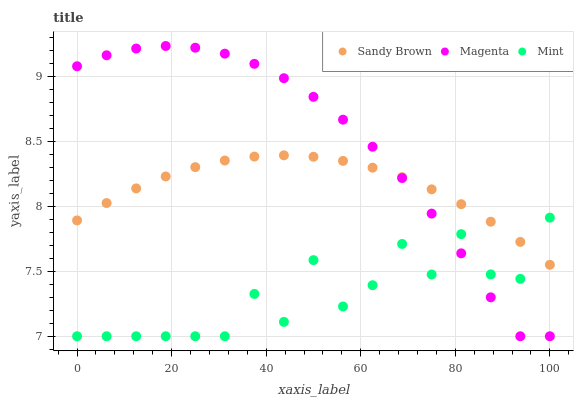Does Mint have the minimum area under the curve?
Answer yes or no. Yes. Does Magenta have the maximum area under the curve?
Answer yes or no. Yes. Does Sandy Brown have the minimum area under the curve?
Answer yes or no. No. Does Sandy Brown have the maximum area under the curve?
Answer yes or no. No. Is Sandy Brown the smoothest?
Answer yes or no. Yes. Is Mint the roughest?
Answer yes or no. Yes. Is Magenta the smoothest?
Answer yes or no. No. Is Magenta the roughest?
Answer yes or no. No. Does Mint have the lowest value?
Answer yes or no. Yes. Does Sandy Brown have the lowest value?
Answer yes or no. No. Does Magenta have the highest value?
Answer yes or no. Yes. Does Sandy Brown have the highest value?
Answer yes or no. No. Does Sandy Brown intersect Mint?
Answer yes or no. Yes. Is Sandy Brown less than Mint?
Answer yes or no. No. Is Sandy Brown greater than Mint?
Answer yes or no. No. 